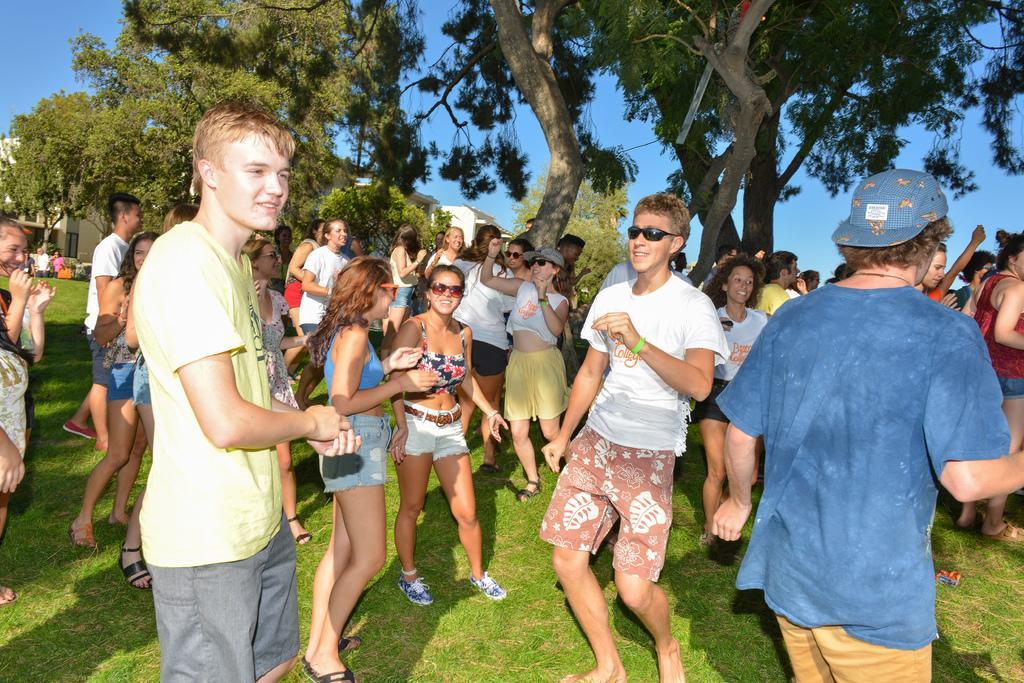Can you describe this image briefly? In this picture I can see number of people in front and I see that they're standing on the grass. In the background I can see the trees, few buildings and the clear sky. 